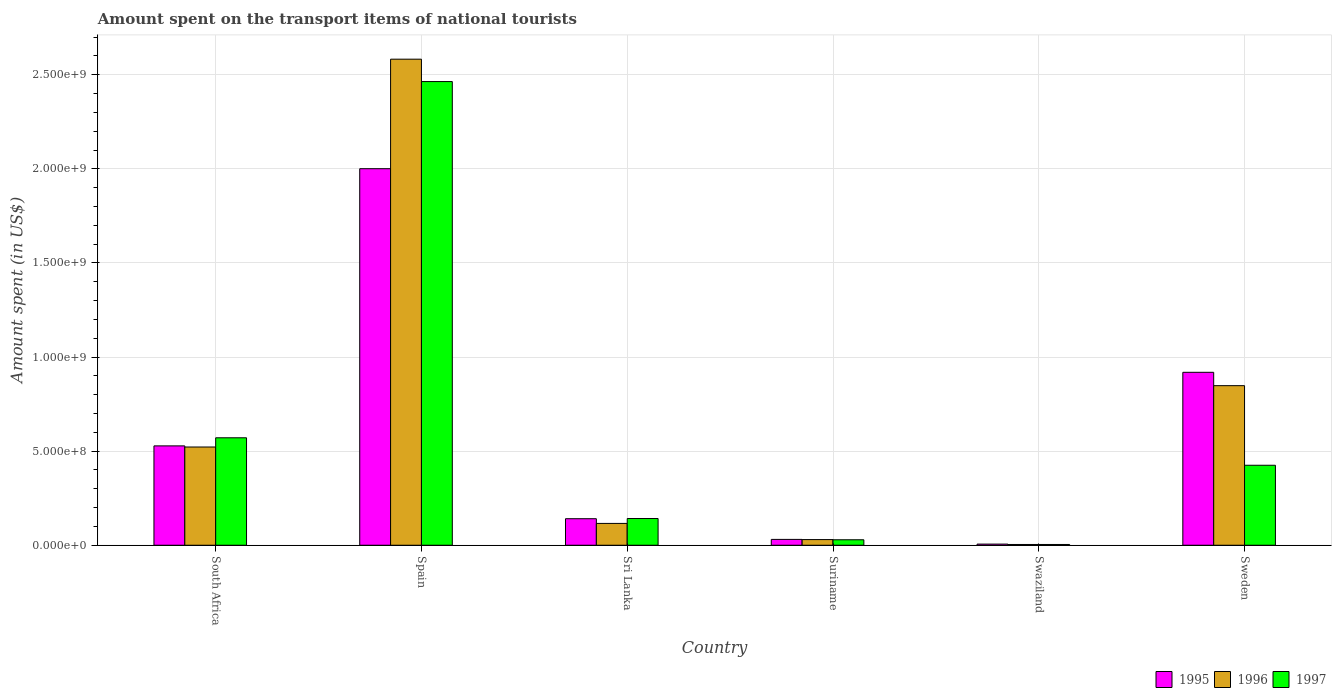How many groups of bars are there?
Your response must be concise. 6. How many bars are there on the 4th tick from the left?
Make the answer very short. 3. What is the label of the 1st group of bars from the left?
Your answer should be compact. South Africa. What is the amount spent on the transport items of national tourists in 1997 in Sri Lanka?
Offer a very short reply. 1.42e+08. Across all countries, what is the maximum amount spent on the transport items of national tourists in 1996?
Your answer should be very brief. 2.58e+09. In which country was the amount spent on the transport items of national tourists in 1996 maximum?
Your answer should be very brief. Spain. In which country was the amount spent on the transport items of national tourists in 1995 minimum?
Your answer should be compact. Swaziland. What is the total amount spent on the transport items of national tourists in 1997 in the graph?
Offer a terse response. 3.64e+09. What is the difference between the amount spent on the transport items of national tourists in 1997 in Suriname and that in Sweden?
Provide a succinct answer. -3.96e+08. What is the difference between the amount spent on the transport items of national tourists in 1996 in Spain and the amount spent on the transport items of national tourists in 1995 in Sweden?
Keep it short and to the point. 1.66e+09. What is the average amount spent on the transport items of national tourists in 1996 per country?
Your answer should be very brief. 6.84e+08. What is the difference between the amount spent on the transport items of national tourists of/in 1996 and amount spent on the transport items of national tourists of/in 1995 in Spain?
Your response must be concise. 5.82e+08. What is the ratio of the amount spent on the transport items of national tourists in 1996 in South Africa to that in Spain?
Offer a very short reply. 0.2. Is the amount spent on the transport items of national tourists in 1995 in Spain less than that in Suriname?
Offer a very short reply. No. Is the difference between the amount spent on the transport items of national tourists in 1996 in South Africa and Swaziland greater than the difference between the amount spent on the transport items of national tourists in 1995 in South Africa and Swaziland?
Make the answer very short. No. What is the difference between the highest and the second highest amount spent on the transport items of national tourists in 1996?
Your response must be concise. 1.74e+09. What is the difference between the highest and the lowest amount spent on the transport items of national tourists in 1997?
Offer a very short reply. 2.46e+09. Is the sum of the amount spent on the transport items of national tourists in 1997 in Spain and Sri Lanka greater than the maximum amount spent on the transport items of national tourists in 1995 across all countries?
Provide a succinct answer. Yes. What does the 3rd bar from the left in Swaziland represents?
Your answer should be compact. 1997. What does the 1st bar from the right in Sweden represents?
Offer a terse response. 1997. Is it the case that in every country, the sum of the amount spent on the transport items of national tourists in 1995 and amount spent on the transport items of national tourists in 1996 is greater than the amount spent on the transport items of national tourists in 1997?
Offer a very short reply. Yes. Are the values on the major ticks of Y-axis written in scientific E-notation?
Offer a terse response. Yes. Where does the legend appear in the graph?
Your response must be concise. Bottom right. How many legend labels are there?
Provide a succinct answer. 3. How are the legend labels stacked?
Keep it short and to the point. Horizontal. What is the title of the graph?
Offer a terse response. Amount spent on the transport items of national tourists. What is the label or title of the X-axis?
Your answer should be compact. Country. What is the label or title of the Y-axis?
Keep it short and to the point. Amount spent (in US$). What is the Amount spent (in US$) in 1995 in South Africa?
Provide a short and direct response. 5.28e+08. What is the Amount spent (in US$) in 1996 in South Africa?
Make the answer very short. 5.22e+08. What is the Amount spent (in US$) in 1997 in South Africa?
Your response must be concise. 5.71e+08. What is the Amount spent (in US$) in 1995 in Spain?
Keep it short and to the point. 2.00e+09. What is the Amount spent (in US$) of 1996 in Spain?
Provide a short and direct response. 2.58e+09. What is the Amount spent (in US$) in 1997 in Spain?
Make the answer very short. 2.46e+09. What is the Amount spent (in US$) in 1995 in Sri Lanka?
Make the answer very short. 1.41e+08. What is the Amount spent (in US$) of 1996 in Sri Lanka?
Your response must be concise. 1.16e+08. What is the Amount spent (in US$) of 1997 in Sri Lanka?
Offer a terse response. 1.42e+08. What is the Amount spent (in US$) of 1995 in Suriname?
Offer a very short reply. 3.10e+07. What is the Amount spent (in US$) in 1996 in Suriname?
Provide a short and direct response. 3.00e+07. What is the Amount spent (in US$) in 1997 in Suriname?
Give a very brief answer. 2.90e+07. What is the Amount spent (in US$) of 1997 in Swaziland?
Your answer should be compact. 4.00e+06. What is the Amount spent (in US$) in 1995 in Sweden?
Offer a very short reply. 9.19e+08. What is the Amount spent (in US$) in 1996 in Sweden?
Your answer should be compact. 8.48e+08. What is the Amount spent (in US$) of 1997 in Sweden?
Offer a very short reply. 4.25e+08. Across all countries, what is the maximum Amount spent (in US$) of 1995?
Provide a succinct answer. 2.00e+09. Across all countries, what is the maximum Amount spent (in US$) of 1996?
Your answer should be very brief. 2.58e+09. Across all countries, what is the maximum Amount spent (in US$) of 1997?
Keep it short and to the point. 2.46e+09. Across all countries, what is the minimum Amount spent (in US$) in 1995?
Your answer should be compact. 6.00e+06. Across all countries, what is the minimum Amount spent (in US$) of 1996?
Offer a very short reply. 4.00e+06. What is the total Amount spent (in US$) of 1995 in the graph?
Offer a terse response. 3.63e+09. What is the total Amount spent (in US$) of 1996 in the graph?
Your response must be concise. 4.10e+09. What is the total Amount spent (in US$) in 1997 in the graph?
Offer a very short reply. 3.64e+09. What is the difference between the Amount spent (in US$) in 1995 in South Africa and that in Spain?
Your response must be concise. -1.47e+09. What is the difference between the Amount spent (in US$) in 1996 in South Africa and that in Spain?
Make the answer very short. -2.06e+09. What is the difference between the Amount spent (in US$) of 1997 in South Africa and that in Spain?
Offer a terse response. -1.89e+09. What is the difference between the Amount spent (in US$) of 1995 in South Africa and that in Sri Lanka?
Your response must be concise. 3.87e+08. What is the difference between the Amount spent (in US$) in 1996 in South Africa and that in Sri Lanka?
Your response must be concise. 4.06e+08. What is the difference between the Amount spent (in US$) in 1997 in South Africa and that in Sri Lanka?
Make the answer very short. 4.29e+08. What is the difference between the Amount spent (in US$) in 1995 in South Africa and that in Suriname?
Ensure brevity in your answer.  4.97e+08. What is the difference between the Amount spent (in US$) of 1996 in South Africa and that in Suriname?
Offer a very short reply. 4.92e+08. What is the difference between the Amount spent (in US$) of 1997 in South Africa and that in Suriname?
Offer a very short reply. 5.42e+08. What is the difference between the Amount spent (in US$) in 1995 in South Africa and that in Swaziland?
Your response must be concise. 5.22e+08. What is the difference between the Amount spent (in US$) in 1996 in South Africa and that in Swaziland?
Your response must be concise. 5.18e+08. What is the difference between the Amount spent (in US$) of 1997 in South Africa and that in Swaziland?
Provide a short and direct response. 5.67e+08. What is the difference between the Amount spent (in US$) in 1995 in South Africa and that in Sweden?
Offer a terse response. -3.91e+08. What is the difference between the Amount spent (in US$) of 1996 in South Africa and that in Sweden?
Provide a succinct answer. -3.26e+08. What is the difference between the Amount spent (in US$) of 1997 in South Africa and that in Sweden?
Give a very brief answer. 1.46e+08. What is the difference between the Amount spent (in US$) in 1995 in Spain and that in Sri Lanka?
Provide a short and direct response. 1.86e+09. What is the difference between the Amount spent (in US$) of 1996 in Spain and that in Sri Lanka?
Give a very brief answer. 2.47e+09. What is the difference between the Amount spent (in US$) of 1997 in Spain and that in Sri Lanka?
Your answer should be compact. 2.32e+09. What is the difference between the Amount spent (in US$) of 1995 in Spain and that in Suriname?
Make the answer very short. 1.97e+09. What is the difference between the Amount spent (in US$) of 1996 in Spain and that in Suriname?
Offer a terse response. 2.55e+09. What is the difference between the Amount spent (in US$) of 1997 in Spain and that in Suriname?
Give a very brief answer. 2.44e+09. What is the difference between the Amount spent (in US$) in 1995 in Spain and that in Swaziland?
Keep it short and to the point. 2.00e+09. What is the difference between the Amount spent (in US$) of 1996 in Spain and that in Swaziland?
Ensure brevity in your answer.  2.58e+09. What is the difference between the Amount spent (in US$) in 1997 in Spain and that in Swaziland?
Provide a succinct answer. 2.46e+09. What is the difference between the Amount spent (in US$) of 1995 in Spain and that in Sweden?
Provide a succinct answer. 1.08e+09. What is the difference between the Amount spent (in US$) in 1996 in Spain and that in Sweden?
Provide a short and direct response. 1.74e+09. What is the difference between the Amount spent (in US$) of 1997 in Spain and that in Sweden?
Provide a short and direct response. 2.04e+09. What is the difference between the Amount spent (in US$) in 1995 in Sri Lanka and that in Suriname?
Your answer should be compact. 1.10e+08. What is the difference between the Amount spent (in US$) of 1996 in Sri Lanka and that in Suriname?
Your answer should be compact. 8.60e+07. What is the difference between the Amount spent (in US$) of 1997 in Sri Lanka and that in Suriname?
Your response must be concise. 1.13e+08. What is the difference between the Amount spent (in US$) in 1995 in Sri Lanka and that in Swaziland?
Your response must be concise. 1.35e+08. What is the difference between the Amount spent (in US$) in 1996 in Sri Lanka and that in Swaziland?
Your answer should be compact. 1.12e+08. What is the difference between the Amount spent (in US$) of 1997 in Sri Lanka and that in Swaziland?
Keep it short and to the point. 1.38e+08. What is the difference between the Amount spent (in US$) of 1995 in Sri Lanka and that in Sweden?
Offer a very short reply. -7.78e+08. What is the difference between the Amount spent (in US$) of 1996 in Sri Lanka and that in Sweden?
Provide a succinct answer. -7.32e+08. What is the difference between the Amount spent (in US$) of 1997 in Sri Lanka and that in Sweden?
Your response must be concise. -2.83e+08. What is the difference between the Amount spent (in US$) of 1995 in Suriname and that in Swaziland?
Keep it short and to the point. 2.50e+07. What is the difference between the Amount spent (in US$) of 1996 in Suriname and that in Swaziland?
Keep it short and to the point. 2.60e+07. What is the difference between the Amount spent (in US$) of 1997 in Suriname and that in Swaziland?
Give a very brief answer. 2.50e+07. What is the difference between the Amount spent (in US$) of 1995 in Suriname and that in Sweden?
Offer a terse response. -8.88e+08. What is the difference between the Amount spent (in US$) of 1996 in Suriname and that in Sweden?
Provide a succinct answer. -8.18e+08. What is the difference between the Amount spent (in US$) in 1997 in Suriname and that in Sweden?
Make the answer very short. -3.96e+08. What is the difference between the Amount spent (in US$) in 1995 in Swaziland and that in Sweden?
Your answer should be very brief. -9.13e+08. What is the difference between the Amount spent (in US$) of 1996 in Swaziland and that in Sweden?
Offer a very short reply. -8.44e+08. What is the difference between the Amount spent (in US$) in 1997 in Swaziland and that in Sweden?
Offer a very short reply. -4.21e+08. What is the difference between the Amount spent (in US$) in 1995 in South Africa and the Amount spent (in US$) in 1996 in Spain?
Your answer should be very brief. -2.06e+09. What is the difference between the Amount spent (in US$) of 1995 in South Africa and the Amount spent (in US$) of 1997 in Spain?
Make the answer very short. -1.94e+09. What is the difference between the Amount spent (in US$) of 1996 in South Africa and the Amount spent (in US$) of 1997 in Spain?
Provide a succinct answer. -1.94e+09. What is the difference between the Amount spent (in US$) of 1995 in South Africa and the Amount spent (in US$) of 1996 in Sri Lanka?
Give a very brief answer. 4.12e+08. What is the difference between the Amount spent (in US$) in 1995 in South Africa and the Amount spent (in US$) in 1997 in Sri Lanka?
Your answer should be compact. 3.86e+08. What is the difference between the Amount spent (in US$) in 1996 in South Africa and the Amount spent (in US$) in 1997 in Sri Lanka?
Keep it short and to the point. 3.80e+08. What is the difference between the Amount spent (in US$) of 1995 in South Africa and the Amount spent (in US$) of 1996 in Suriname?
Offer a terse response. 4.98e+08. What is the difference between the Amount spent (in US$) of 1995 in South Africa and the Amount spent (in US$) of 1997 in Suriname?
Make the answer very short. 4.99e+08. What is the difference between the Amount spent (in US$) of 1996 in South Africa and the Amount spent (in US$) of 1997 in Suriname?
Your response must be concise. 4.93e+08. What is the difference between the Amount spent (in US$) of 1995 in South Africa and the Amount spent (in US$) of 1996 in Swaziland?
Provide a succinct answer. 5.24e+08. What is the difference between the Amount spent (in US$) in 1995 in South Africa and the Amount spent (in US$) in 1997 in Swaziland?
Make the answer very short. 5.24e+08. What is the difference between the Amount spent (in US$) in 1996 in South Africa and the Amount spent (in US$) in 1997 in Swaziland?
Your response must be concise. 5.18e+08. What is the difference between the Amount spent (in US$) in 1995 in South Africa and the Amount spent (in US$) in 1996 in Sweden?
Keep it short and to the point. -3.20e+08. What is the difference between the Amount spent (in US$) of 1995 in South Africa and the Amount spent (in US$) of 1997 in Sweden?
Keep it short and to the point. 1.03e+08. What is the difference between the Amount spent (in US$) of 1996 in South Africa and the Amount spent (in US$) of 1997 in Sweden?
Your response must be concise. 9.70e+07. What is the difference between the Amount spent (in US$) of 1995 in Spain and the Amount spent (in US$) of 1996 in Sri Lanka?
Ensure brevity in your answer.  1.88e+09. What is the difference between the Amount spent (in US$) of 1995 in Spain and the Amount spent (in US$) of 1997 in Sri Lanka?
Provide a short and direct response. 1.86e+09. What is the difference between the Amount spent (in US$) of 1996 in Spain and the Amount spent (in US$) of 1997 in Sri Lanka?
Provide a succinct answer. 2.44e+09. What is the difference between the Amount spent (in US$) in 1995 in Spain and the Amount spent (in US$) in 1996 in Suriname?
Make the answer very short. 1.97e+09. What is the difference between the Amount spent (in US$) of 1995 in Spain and the Amount spent (in US$) of 1997 in Suriname?
Ensure brevity in your answer.  1.97e+09. What is the difference between the Amount spent (in US$) of 1996 in Spain and the Amount spent (in US$) of 1997 in Suriname?
Make the answer very short. 2.55e+09. What is the difference between the Amount spent (in US$) of 1995 in Spain and the Amount spent (in US$) of 1996 in Swaziland?
Offer a terse response. 2.00e+09. What is the difference between the Amount spent (in US$) of 1995 in Spain and the Amount spent (in US$) of 1997 in Swaziland?
Offer a terse response. 2.00e+09. What is the difference between the Amount spent (in US$) of 1996 in Spain and the Amount spent (in US$) of 1997 in Swaziland?
Make the answer very short. 2.58e+09. What is the difference between the Amount spent (in US$) of 1995 in Spain and the Amount spent (in US$) of 1996 in Sweden?
Your answer should be compact. 1.15e+09. What is the difference between the Amount spent (in US$) of 1995 in Spain and the Amount spent (in US$) of 1997 in Sweden?
Ensure brevity in your answer.  1.58e+09. What is the difference between the Amount spent (in US$) in 1996 in Spain and the Amount spent (in US$) in 1997 in Sweden?
Give a very brief answer. 2.16e+09. What is the difference between the Amount spent (in US$) of 1995 in Sri Lanka and the Amount spent (in US$) of 1996 in Suriname?
Make the answer very short. 1.11e+08. What is the difference between the Amount spent (in US$) of 1995 in Sri Lanka and the Amount spent (in US$) of 1997 in Suriname?
Offer a very short reply. 1.12e+08. What is the difference between the Amount spent (in US$) in 1996 in Sri Lanka and the Amount spent (in US$) in 1997 in Suriname?
Offer a very short reply. 8.70e+07. What is the difference between the Amount spent (in US$) in 1995 in Sri Lanka and the Amount spent (in US$) in 1996 in Swaziland?
Offer a very short reply. 1.37e+08. What is the difference between the Amount spent (in US$) in 1995 in Sri Lanka and the Amount spent (in US$) in 1997 in Swaziland?
Give a very brief answer. 1.37e+08. What is the difference between the Amount spent (in US$) of 1996 in Sri Lanka and the Amount spent (in US$) of 1997 in Swaziland?
Make the answer very short. 1.12e+08. What is the difference between the Amount spent (in US$) in 1995 in Sri Lanka and the Amount spent (in US$) in 1996 in Sweden?
Ensure brevity in your answer.  -7.07e+08. What is the difference between the Amount spent (in US$) in 1995 in Sri Lanka and the Amount spent (in US$) in 1997 in Sweden?
Your answer should be very brief. -2.84e+08. What is the difference between the Amount spent (in US$) of 1996 in Sri Lanka and the Amount spent (in US$) of 1997 in Sweden?
Offer a very short reply. -3.09e+08. What is the difference between the Amount spent (in US$) of 1995 in Suriname and the Amount spent (in US$) of 1996 in Swaziland?
Make the answer very short. 2.70e+07. What is the difference between the Amount spent (in US$) of 1995 in Suriname and the Amount spent (in US$) of 1997 in Swaziland?
Make the answer very short. 2.70e+07. What is the difference between the Amount spent (in US$) of 1996 in Suriname and the Amount spent (in US$) of 1997 in Swaziland?
Provide a succinct answer. 2.60e+07. What is the difference between the Amount spent (in US$) of 1995 in Suriname and the Amount spent (in US$) of 1996 in Sweden?
Offer a terse response. -8.17e+08. What is the difference between the Amount spent (in US$) in 1995 in Suriname and the Amount spent (in US$) in 1997 in Sweden?
Give a very brief answer. -3.94e+08. What is the difference between the Amount spent (in US$) in 1996 in Suriname and the Amount spent (in US$) in 1997 in Sweden?
Ensure brevity in your answer.  -3.95e+08. What is the difference between the Amount spent (in US$) of 1995 in Swaziland and the Amount spent (in US$) of 1996 in Sweden?
Provide a succinct answer. -8.42e+08. What is the difference between the Amount spent (in US$) in 1995 in Swaziland and the Amount spent (in US$) in 1997 in Sweden?
Ensure brevity in your answer.  -4.19e+08. What is the difference between the Amount spent (in US$) in 1996 in Swaziland and the Amount spent (in US$) in 1997 in Sweden?
Offer a very short reply. -4.21e+08. What is the average Amount spent (in US$) in 1995 per country?
Your response must be concise. 6.04e+08. What is the average Amount spent (in US$) in 1996 per country?
Provide a succinct answer. 6.84e+08. What is the average Amount spent (in US$) in 1997 per country?
Offer a very short reply. 6.06e+08. What is the difference between the Amount spent (in US$) in 1995 and Amount spent (in US$) in 1996 in South Africa?
Your answer should be very brief. 6.00e+06. What is the difference between the Amount spent (in US$) in 1995 and Amount spent (in US$) in 1997 in South Africa?
Ensure brevity in your answer.  -4.30e+07. What is the difference between the Amount spent (in US$) of 1996 and Amount spent (in US$) of 1997 in South Africa?
Keep it short and to the point. -4.90e+07. What is the difference between the Amount spent (in US$) of 1995 and Amount spent (in US$) of 1996 in Spain?
Provide a short and direct response. -5.82e+08. What is the difference between the Amount spent (in US$) in 1995 and Amount spent (in US$) in 1997 in Spain?
Your response must be concise. -4.63e+08. What is the difference between the Amount spent (in US$) of 1996 and Amount spent (in US$) of 1997 in Spain?
Keep it short and to the point. 1.19e+08. What is the difference between the Amount spent (in US$) of 1995 and Amount spent (in US$) of 1996 in Sri Lanka?
Ensure brevity in your answer.  2.50e+07. What is the difference between the Amount spent (in US$) of 1996 and Amount spent (in US$) of 1997 in Sri Lanka?
Keep it short and to the point. -2.60e+07. What is the difference between the Amount spent (in US$) in 1995 and Amount spent (in US$) in 1996 in Suriname?
Ensure brevity in your answer.  1.00e+06. What is the difference between the Amount spent (in US$) of 1995 and Amount spent (in US$) of 1996 in Swaziland?
Offer a terse response. 2.00e+06. What is the difference between the Amount spent (in US$) in 1996 and Amount spent (in US$) in 1997 in Swaziland?
Provide a short and direct response. 0. What is the difference between the Amount spent (in US$) of 1995 and Amount spent (in US$) of 1996 in Sweden?
Offer a terse response. 7.10e+07. What is the difference between the Amount spent (in US$) of 1995 and Amount spent (in US$) of 1997 in Sweden?
Offer a terse response. 4.94e+08. What is the difference between the Amount spent (in US$) of 1996 and Amount spent (in US$) of 1997 in Sweden?
Provide a short and direct response. 4.23e+08. What is the ratio of the Amount spent (in US$) of 1995 in South Africa to that in Spain?
Make the answer very short. 0.26. What is the ratio of the Amount spent (in US$) in 1996 in South Africa to that in Spain?
Your answer should be compact. 0.2. What is the ratio of the Amount spent (in US$) in 1997 in South Africa to that in Spain?
Provide a short and direct response. 0.23. What is the ratio of the Amount spent (in US$) of 1995 in South Africa to that in Sri Lanka?
Your answer should be compact. 3.74. What is the ratio of the Amount spent (in US$) of 1996 in South Africa to that in Sri Lanka?
Your answer should be very brief. 4.5. What is the ratio of the Amount spent (in US$) of 1997 in South Africa to that in Sri Lanka?
Keep it short and to the point. 4.02. What is the ratio of the Amount spent (in US$) of 1995 in South Africa to that in Suriname?
Provide a short and direct response. 17.03. What is the ratio of the Amount spent (in US$) of 1996 in South Africa to that in Suriname?
Your response must be concise. 17.4. What is the ratio of the Amount spent (in US$) in 1997 in South Africa to that in Suriname?
Offer a terse response. 19.69. What is the ratio of the Amount spent (in US$) in 1995 in South Africa to that in Swaziland?
Offer a very short reply. 88. What is the ratio of the Amount spent (in US$) in 1996 in South Africa to that in Swaziland?
Offer a terse response. 130.5. What is the ratio of the Amount spent (in US$) in 1997 in South Africa to that in Swaziland?
Make the answer very short. 142.75. What is the ratio of the Amount spent (in US$) of 1995 in South Africa to that in Sweden?
Provide a succinct answer. 0.57. What is the ratio of the Amount spent (in US$) of 1996 in South Africa to that in Sweden?
Provide a short and direct response. 0.62. What is the ratio of the Amount spent (in US$) of 1997 in South Africa to that in Sweden?
Ensure brevity in your answer.  1.34. What is the ratio of the Amount spent (in US$) of 1995 in Spain to that in Sri Lanka?
Your answer should be very brief. 14.19. What is the ratio of the Amount spent (in US$) in 1996 in Spain to that in Sri Lanka?
Offer a terse response. 22.27. What is the ratio of the Amount spent (in US$) of 1997 in Spain to that in Sri Lanka?
Keep it short and to the point. 17.35. What is the ratio of the Amount spent (in US$) of 1995 in Spain to that in Suriname?
Give a very brief answer. 64.55. What is the ratio of the Amount spent (in US$) in 1996 in Spain to that in Suriname?
Ensure brevity in your answer.  86.1. What is the ratio of the Amount spent (in US$) in 1997 in Spain to that in Suriname?
Your answer should be very brief. 84.97. What is the ratio of the Amount spent (in US$) in 1995 in Spain to that in Swaziland?
Provide a succinct answer. 333.5. What is the ratio of the Amount spent (in US$) in 1996 in Spain to that in Swaziland?
Your answer should be very brief. 645.75. What is the ratio of the Amount spent (in US$) of 1997 in Spain to that in Swaziland?
Your answer should be compact. 616. What is the ratio of the Amount spent (in US$) in 1995 in Spain to that in Sweden?
Your response must be concise. 2.18. What is the ratio of the Amount spent (in US$) in 1996 in Spain to that in Sweden?
Your answer should be compact. 3.05. What is the ratio of the Amount spent (in US$) of 1997 in Spain to that in Sweden?
Offer a very short reply. 5.8. What is the ratio of the Amount spent (in US$) of 1995 in Sri Lanka to that in Suriname?
Make the answer very short. 4.55. What is the ratio of the Amount spent (in US$) of 1996 in Sri Lanka to that in Suriname?
Your response must be concise. 3.87. What is the ratio of the Amount spent (in US$) of 1997 in Sri Lanka to that in Suriname?
Ensure brevity in your answer.  4.9. What is the ratio of the Amount spent (in US$) of 1995 in Sri Lanka to that in Swaziland?
Your response must be concise. 23.5. What is the ratio of the Amount spent (in US$) of 1997 in Sri Lanka to that in Swaziland?
Your answer should be compact. 35.5. What is the ratio of the Amount spent (in US$) in 1995 in Sri Lanka to that in Sweden?
Keep it short and to the point. 0.15. What is the ratio of the Amount spent (in US$) of 1996 in Sri Lanka to that in Sweden?
Your response must be concise. 0.14. What is the ratio of the Amount spent (in US$) in 1997 in Sri Lanka to that in Sweden?
Offer a terse response. 0.33. What is the ratio of the Amount spent (in US$) in 1995 in Suriname to that in Swaziland?
Your answer should be compact. 5.17. What is the ratio of the Amount spent (in US$) in 1996 in Suriname to that in Swaziland?
Offer a very short reply. 7.5. What is the ratio of the Amount spent (in US$) of 1997 in Suriname to that in Swaziland?
Provide a succinct answer. 7.25. What is the ratio of the Amount spent (in US$) in 1995 in Suriname to that in Sweden?
Offer a terse response. 0.03. What is the ratio of the Amount spent (in US$) in 1996 in Suriname to that in Sweden?
Your answer should be compact. 0.04. What is the ratio of the Amount spent (in US$) in 1997 in Suriname to that in Sweden?
Offer a very short reply. 0.07. What is the ratio of the Amount spent (in US$) in 1995 in Swaziland to that in Sweden?
Your answer should be compact. 0.01. What is the ratio of the Amount spent (in US$) of 1996 in Swaziland to that in Sweden?
Provide a short and direct response. 0. What is the ratio of the Amount spent (in US$) in 1997 in Swaziland to that in Sweden?
Provide a succinct answer. 0.01. What is the difference between the highest and the second highest Amount spent (in US$) in 1995?
Give a very brief answer. 1.08e+09. What is the difference between the highest and the second highest Amount spent (in US$) in 1996?
Make the answer very short. 1.74e+09. What is the difference between the highest and the second highest Amount spent (in US$) in 1997?
Keep it short and to the point. 1.89e+09. What is the difference between the highest and the lowest Amount spent (in US$) in 1995?
Ensure brevity in your answer.  2.00e+09. What is the difference between the highest and the lowest Amount spent (in US$) in 1996?
Ensure brevity in your answer.  2.58e+09. What is the difference between the highest and the lowest Amount spent (in US$) of 1997?
Your answer should be compact. 2.46e+09. 